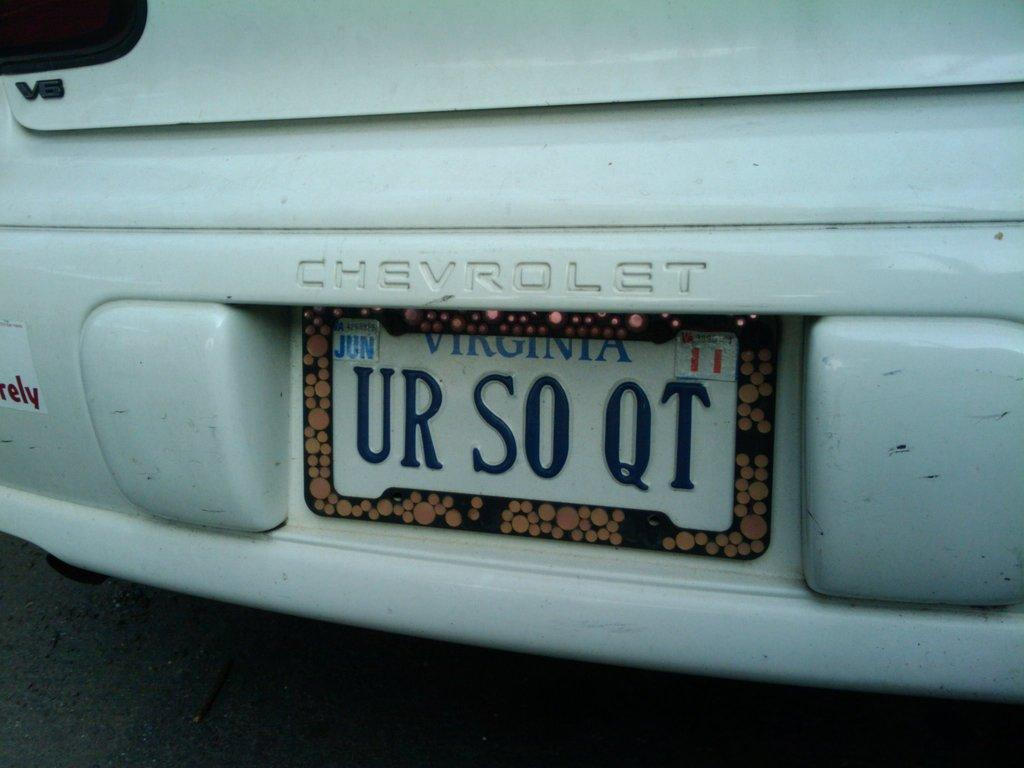<image>
Share a concise interpretation of the image provided. A white Chevrolet with the license plate UR SO QT. 